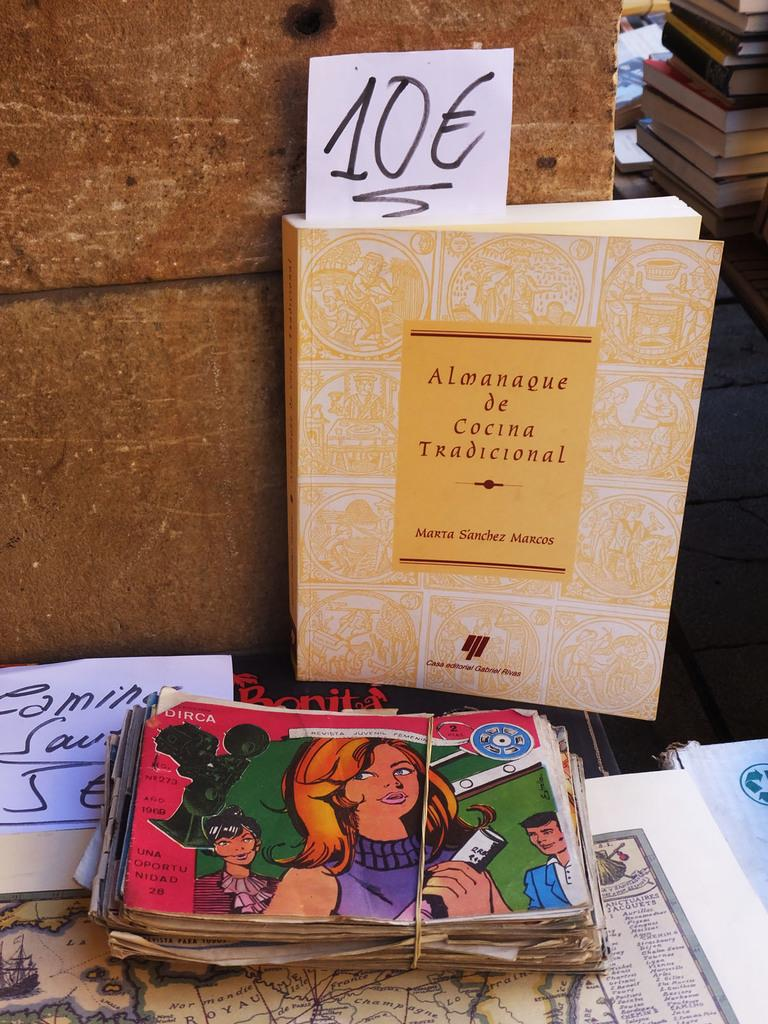<image>
Give a short and clear explanation of the subsequent image. Used books for sale on a table one of them written by Marta Sanchez Marcos. 